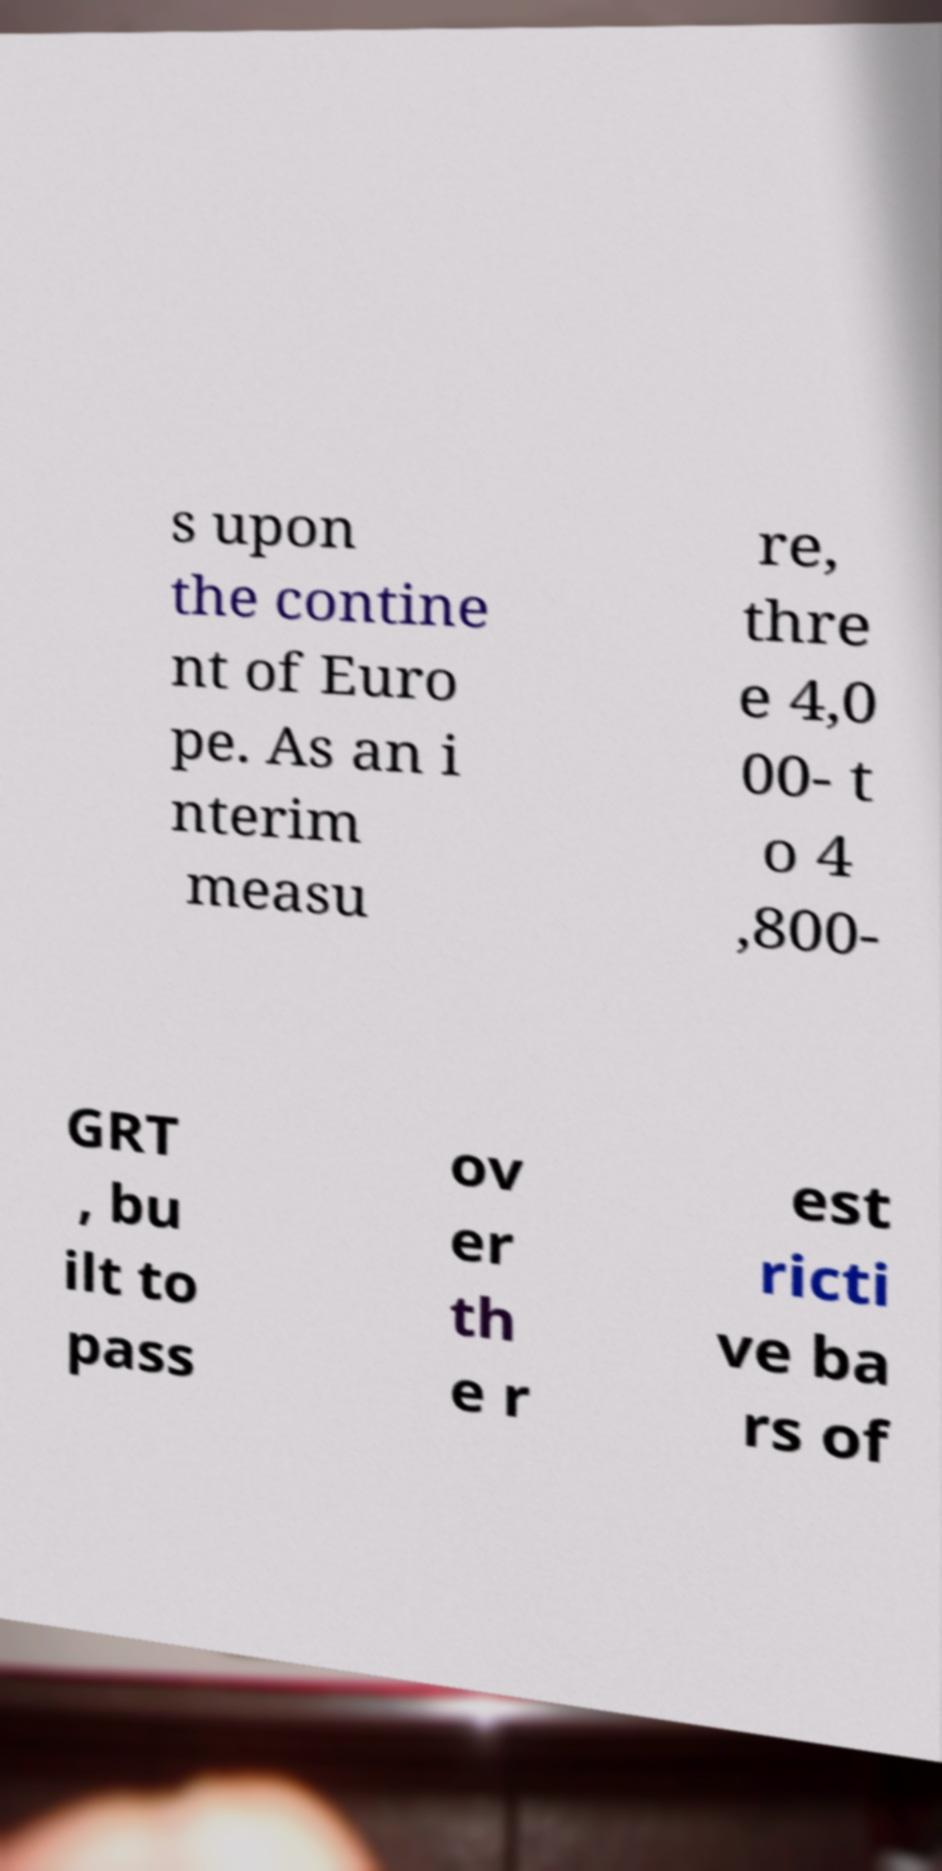Can you accurately transcribe the text from the provided image for me? s upon the contine nt of Euro pe. As an i nterim measu re, thre e 4,0 00- t o 4 ,800- GRT , bu ilt to pass ov er th e r est ricti ve ba rs of 